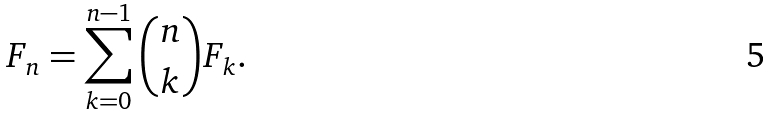Convert formula to latex. <formula><loc_0><loc_0><loc_500><loc_500>F _ { n } = \sum _ { k = 0 } ^ { n - 1 } \binom { n } { k } F _ { k } .</formula> 